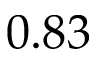<formula> <loc_0><loc_0><loc_500><loc_500>0 . 8 3</formula> 